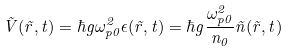<formula> <loc_0><loc_0><loc_500><loc_500>\tilde { V } ( \vec { r } , t ) = \hbar { g } \omega _ { p 0 } ^ { 2 } \epsilon ( \vec { r } , t ) = \hbar { g } \frac { \omega _ { p 0 } ^ { 2 } } { n _ { 0 } } \tilde { n } ( \vec { r } , t )</formula> 